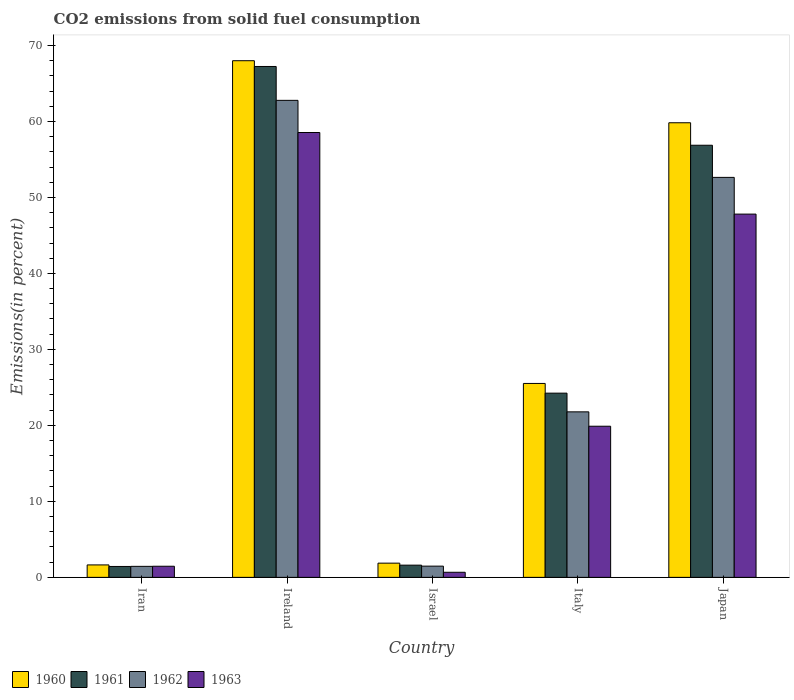How many different coloured bars are there?
Offer a very short reply. 4. How many groups of bars are there?
Your answer should be compact. 5. Are the number of bars per tick equal to the number of legend labels?
Provide a succinct answer. Yes. How many bars are there on the 3rd tick from the left?
Give a very brief answer. 4. What is the total CO2 emitted in 1961 in Japan?
Your response must be concise. 56.87. Across all countries, what is the maximum total CO2 emitted in 1962?
Your response must be concise. 62.77. Across all countries, what is the minimum total CO2 emitted in 1960?
Make the answer very short. 1.64. In which country was the total CO2 emitted in 1962 maximum?
Keep it short and to the point. Ireland. In which country was the total CO2 emitted in 1960 minimum?
Provide a short and direct response. Iran. What is the total total CO2 emitted in 1963 in the graph?
Keep it short and to the point. 128.36. What is the difference between the total CO2 emitted in 1963 in Iran and that in Ireland?
Your answer should be very brief. -57.08. What is the difference between the total CO2 emitted in 1960 in Ireland and the total CO2 emitted in 1961 in Iran?
Provide a succinct answer. 66.55. What is the average total CO2 emitted in 1961 per country?
Your response must be concise. 30.28. What is the difference between the total CO2 emitted of/in 1963 and total CO2 emitted of/in 1960 in Iran?
Your response must be concise. -0.17. What is the ratio of the total CO2 emitted in 1961 in Ireland to that in Italy?
Your answer should be compact. 2.77. Is the total CO2 emitted in 1963 in Ireland less than that in Italy?
Keep it short and to the point. No. Is the difference between the total CO2 emitted in 1963 in Iran and Ireland greater than the difference between the total CO2 emitted in 1960 in Iran and Ireland?
Ensure brevity in your answer.  Yes. What is the difference between the highest and the second highest total CO2 emitted in 1961?
Provide a succinct answer. 32.62. What is the difference between the highest and the lowest total CO2 emitted in 1960?
Your answer should be very brief. 66.35. Is the sum of the total CO2 emitted in 1961 in Iran and Ireland greater than the maximum total CO2 emitted in 1962 across all countries?
Keep it short and to the point. Yes. Is it the case that in every country, the sum of the total CO2 emitted in 1961 and total CO2 emitted in 1960 is greater than the total CO2 emitted in 1963?
Give a very brief answer. Yes. How many bars are there?
Your answer should be compact. 20. How many countries are there in the graph?
Make the answer very short. 5. What is the difference between two consecutive major ticks on the Y-axis?
Your answer should be very brief. 10. Are the values on the major ticks of Y-axis written in scientific E-notation?
Make the answer very short. No. Does the graph contain any zero values?
Provide a succinct answer. No. Does the graph contain grids?
Your answer should be compact. No. How are the legend labels stacked?
Provide a short and direct response. Horizontal. What is the title of the graph?
Provide a short and direct response. CO2 emissions from solid fuel consumption. What is the label or title of the X-axis?
Offer a terse response. Country. What is the label or title of the Y-axis?
Keep it short and to the point. Emissions(in percent). What is the Emissions(in percent) of 1960 in Iran?
Your answer should be very brief. 1.64. What is the Emissions(in percent) in 1961 in Iran?
Your answer should be compact. 1.44. What is the Emissions(in percent) of 1962 in Iran?
Make the answer very short. 1.45. What is the Emissions(in percent) in 1963 in Iran?
Your answer should be compact. 1.46. What is the Emissions(in percent) of 1960 in Ireland?
Offer a terse response. 67.99. What is the Emissions(in percent) of 1961 in Ireland?
Offer a terse response. 67.23. What is the Emissions(in percent) in 1962 in Ireland?
Provide a short and direct response. 62.77. What is the Emissions(in percent) of 1963 in Ireland?
Ensure brevity in your answer.  58.54. What is the Emissions(in percent) of 1960 in Israel?
Your answer should be compact. 1.87. What is the Emissions(in percent) of 1961 in Israel?
Keep it short and to the point. 1.61. What is the Emissions(in percent) in 1962 in Israel?
Your response must be concise. 1.48. What is the Emissions(in percent) of 1963 in Israel?
Your answer should be compact. 0.67. What is the Emissions(in percent) of 1960 in Italy?
Offer a very short reply. 25.52. What is the Emissions(in percent) in 1961 in Italy?
Keep it short and to the point. 24.24. What is the Emissions(in percent) of 1962 in Italy?
Your answer should be compact. 21.78. What is the Emissions(in percent) of 1963 in Italy?
Offer a terse response. 19.89. What is the Emissions(in percent) of 1960 in Japan?
Offer a terse response. 59.82. What is the Emissions(in percent) in 1961 in Japan?
Keep it short and to the point. 56.87. What is the Emissions(in percent) in 1962 in Japan?
Offer a terse response. 52.64. What is the Emissions(in percent) of 1963 in Japan?
Offer a terse response. 47.8. Across all countries, what is the maximum Emissions(in percent) in 1960?
Your response must be concise. 67.99. Across all countries, what is the maximum Emissions(in percent) of 1961?
Your answer should be compact. 67.23. Across all countries, what is the maximum Emissions(in percent) of 1962?
Your answer should be very brief. 62.77. Across all countries, what is the maximum Emissions(in percent) of 1963?
Ensure brevity in your answer.  58.54. Across all countries, what is the minimum Emissions(in percent) in 1960?
Offer a very short reply. 1.64. Across all countries, what is the minimum Emissions(in percent) of 1961?
Your answer should be very brief. 1.44. Across all countries, what is the minimum Emissions(in percent) in 1962?
Offer a very short reply. 1.45. Across all countries, what is the minimum Emissions(in percent) in 1963?
Give a very brief answer. 0.67. What is the total Emissions(in percent) of 1960 in the graph?
Offer a very short reply. 156.84. What is the total Emissions(in percent) of 1961 in the graph?
Your answer should be compact. 151.38. What is the total Emissions(in percent) of 1962 in the graph?
Ensure brevity in your answer.  140.12. What is the total Emissions(in percent) in 1963 in the graph?
Offer a very short reply. 128.36. What is the difference between the Emissions(in percent) of 1960 in Iran and that in Ireland?
Your answer should be compact. -66.35. What is the difference between the Emissions(in percent) of 1961 in Iran and that in Ireland?
Provide a succinct answer. -65.8. What is the difference between the Emissions(in percent) of 1962 in Iran and that in Ireland?
Your response must be concise. -61.32. What is the difference between the Emissions(in percent) in 1963 in Iran and that in Ireland?
Keep it short and to the point. -57.08. What is the difference between the Emissions(in percent) in 1960 in Iran and that in Israel?
Your answer should be very brief. -0.23. What is the difference between the Emissions(in percent) of 1961 in Iran and that in Israel?
Offer a very short reply. -0.17. What is the difference between the Emissions(in percent) in 1962 in Iran and that in Israel?
Provide a short and direct response. -0.03. What is the difference between the Emissions(in percent) in 1963 in Iran and that in Israel?
Your answer should be compact. 0.79. What is the difference between the Emissions(in percent) in 1960 in Iran and that in Italy?
Offer a terse response. -23.88. What is the difference between the Emissions(in percent) of 1961 in Iran and that in Italy?
Offer a very short reply. -22.81. What is the difference between the Emissions(in percent) of 1962 in Iran and that in Italy?
Make the answer very short. -20.33. What is the difference between the Emissions(in percent) in 1963 in Iran and that in Italy?
Keep it short and to the point. -18.42. What is the difference between the Emissions(in percent) of 1960 in Iran and that in Japan?
Ensure brevity in your answer.  -58.19. What is the difference between the Emissions(in percent) of 1961 in Iran and that in Japan?
Ensure brevity in your answer.  -55.43. What is the difference between the Emissions(in percent) of 1962 in Iran and that in Japan?
Offer a very short reply. -51.19. What is the difference between the Emissions(in percent) of 1963 in Iran and that in Japan?
Make the answer very short. -46.34. What is the difference between the Emissions(in percent) in 1960 in Ireland and that in Israel?
Provide a succinct answer. 66.12. What is the difference between the Emissions(in percent) in 1961 in Ireland and that in Israel?
Your answer should be very brief. 65.62. What is the difference between the Emissions(in percent) of 1962 in Ireland and that in Israel?
Offer a very short reply. 61.3. What is the difference between the Emissions(in percent) in 1963 in Ireland and that in Israel?
Your response must be concise. 57.87. What is the difference between the Emissions(in percent) of 1960 in Ireland and that in Italy?
Keep it short and to the point. 42.47. What is the difference between the Emissions(in percent) of 1961 in Ireland and that in Italy?
Provide a succinct answer. 42.99. What is the difference between the Emissions(in percent) in 1962 in Ireland and that in Italy?
Make the answer very short. 40.99. What is the difference between the Emissions(in percent) in 1963 in Ireland and that in Italy?
Your answer should be compact. 38.65. What is the difference between the Emissions(in percent) of 1960 in Ireland and that in Japan?
Give a very brief answer. 8.17. What is the difference between the Emissions(in percent) of 1961 in Ireland and that in Japan?
Offer a terse response. 10.36. What is the difference between the Emissions(in percent) in 1962 in Ireland and that in Japan?
Your answer should be compact. 10.14. What is the difference between the Emissions(in percent) in 1963 in Ireland and that in Japan?
Give a very brief answer. 10.74. What is the difference between the Emissions(in percent) in 1960 in Israel and that in Italy?
Offer a very short reply. -23.65. What is the difference between the Emissions(in percent) of 1961 in Israel and that in Italy?
Keep it short and to the point. -22.63. What is the difference between the Emissions(in percent) of 1962 in Israel and that in Italy?
Your answer should be compact. -20.3. What is the difference between the Emissions(in percent) in 1963 in Israel and that in Italy?
Your answer should be very brief. -19.22. What is the difference between the Emissions(in percent) in 1960 in Israel and that in Japan?
Your response must be concise. -57.95. What is the difference between the Emissions(in percent) of 1961 in Israel and that in Japan?
Ensure brevity in your answer.  -55.26. What is the difference between the Emissions(in percent) in 1962 in Israel and that in Japan?
Your answer should be very brief. -51.16. What is the difference between the Emissions(in percent) in 1963 in Israel and that in Japan?
Give a very brief answer. -47.13. What is the difference between the Emissions(in percent) in 1960 in Italy and that in Japan?
Offer a very short reply. -34.31. What is the difference between the Emissions(in percent) of 1961 in Italy and that in Japan?
Provide a short and direct response. -32.62. What is the difference between the Emissions(in percent) in 1962 in Italy and that in Japan?
Offer a very short reply. -30.86. What is the difference between the Emissions(in percent) of 1963 in Italy and that in Japan?
Provide a short and direct response. -27.91. What is the difference between the Emissions(in percent) in 1960 in Iran and the Emissions(in percent) in 1961 in Ireland?
Make the answer very short. -65.59. What is the difference between the Emissions(in percent) in 1960 in Iran and the Emissions(in percent) in 1962 in Ireland?
Provide a short and direct response. -61.13. What is the difference between the Emissions(in percent) of 1960 in Iran and the Emissions(in percent) of 1963 in Ireland?
Provide a short and direct response. -56.9. What is the difference between the Emissions(in percent) in 1961 in Iran and the Emissions(in percent) in 1962 in Ireland?
Offer a terse response. -61.34. What is the difference between the Emissions(in percent) of 1961 in Iran and the Emissions(in percent) of 1963 in Ireland?
Your answer should be compact. -57.1. What is the difference between the Emissions(in percent) of 1962 in Iran and the Emissions(in percent) of 1963 in Ireland?
Give a very brief answer. -57.09. What is the difference between the Emissions(in percent) in 1960 in Iran and the Emissions(in percent) in 1961 in Israel?
Ensure brevity in your answer.  0.03. What is the difference between the Emissions(in percent) of 1960 in Iran and the Emissions(in percent) of 1962 in Israel?
Make the answer very short. 0.16. What is the difference between the Emissions(in percent) in 1960 in Iran and the Emissions(in percent) in 1963 in Israel?
Your response must be concise. 0.97. What is the difference between the Emissions(in percent) of 1961 in Iran and the Emissions(in percent) of 1962 in Israel?
Make the answer very short. -0.04. What is the difference between the Emissions(in percent) in 1961 in Iran and the Emissions(in percent) in 1963 in Israel?
Make the answer very short. 0.77. What is the difference between the Emissions(in percent) of 1962 in Iran and the Emissions(in percent) of 1963 in Israel?
Your response must be concise. 0.78. What is the difference between the Emissions(in percent) in 1960 in Iran and the Emissions(in percent) in 1961 in Italy?
Make the answer very short. -22.6. What is the difference between the Emissions(in percent) of 1960 in Iran and the Emissions(in percent) of 1962 in Italy?
Make the answer very short. -20.14. What is the difference between the Emissions(in percent) in 1960 in Iran and the Emissions(in percent) in 1963 in Italy?
Give a very brief answer. -18.25. What is the difference between the Emissions(in percent) in 1961 in Iran and the Emissions(in percent) in 1962 in Italy?
Your answer should be compact. -20.35. What is the difference between the Emissions(in percent) in 1961 in Iran and the Emissions(in percent) in 1963 in Italy?
Ensure brevity in your answer.  -18.45. What is the difference between the Emissions(in percent) of 1962 in Iran and the Emissions(in percent) of 1963 in Italy?
Make the answer very short. -18.44. What is the difference between the Emissions(in percent) of 1960 in Iran and the Emissions(in percent) of 1961 in Japan?
Keep it short and to the point. -55.23. What is the difference between the Emissions(in percent) in 1960 in Iran and the Emissions(in percent) in 1962 in Japan?
Your answer should be very brief. -51. What is the difference between the Emissions(in percent) of 1960 in Iran and the Emissions(in percent) of 1963 in Japan?
Keep it short and to the point. -46.17. What is the difference between the Emissions(in percent) of 1961 in Iran and the Emissions(in percent) of 1962 in Japan?
Provide a succinct answer. -51.2. What is the difference between the Emissions(in percent) of 1961 in Iran and the Emissions(in percent) of 1963 in Japan?
Make the answer very short. -46.37. What is the difference between the Emissions(in percent) in 1962 in Iran and the Emissions(in percent) in 1963 in Japan?
Your response must be concise. -46.35. What is the difference between the Emissions(in percent) of 1960 in Ireland and the Emissions(in percent) of 1961 in Israel?
Provide a short and direct response. 66.38. What is the difference between the Emissions(in percent) in 1960 in Ireland and the Emissions(in percent) in 1962 in Israel?
Your response must be concise. 66.51. What is the difference between the Emissions(in percent) in 1960 in Ireland and the Emissions(in percent) in 1963 in Israel?
Offer a terse response. 67.32. What is the difference between the Emissions(in percent) in 1961 in Ireland and the Emissions(in percent) in 1962 in Israel?
Offer a terse response. 65.75. What is the difference between the Emissions(in percent) in 1961 in Ireland and the Emissions(in percent) in 1963 in Israel?
Offer a terse response. 66.56. What is the difference between the Emissions(in percent) in 1962 in Ireland and the Emissions(in percent) in 1963 in Israel?
Keep it short and to the point. 62.1. What is the difference between the Emissions(in percent) in 1960 in Ireland and the Emissions(in percent) in 1961 in Italy?
Make the answer very short. 43.75. What is the difference between the Emissions(in percent) of 1960 in Ireland and the Emissions(in percent) of 1962 in Italy?
Offer a very short reply. 46.21. What is the difference between the Emissions(in percent) of 1960 in Ireland and the Emissions(in percent) of 1963 in Italy?
Ensure brevity in your answer.  48.1. What is the difference between the Emissions(in percent) of 1961 in Ireland and the Emissions(in percent) of 1962 in Italy?
Ensure brevity in your answer.  45.45. What is the difference between the Emissions(in percent) in 1961 in Ireland and the Emissions(in percent) in 1963 in Italy?
Give a very brief answer. 47.34. What is the difference between the Emissions(in percent) of 1962 in Ireland and the Emissions(in percent) of 1963 in Italy?
Make the answer very short. 42.88. What is the difference between the Emissions(in percent) in 1960 in Ireland and the Emissions(in percent) in 1961 in Japan?
Ensure brevity in your answer.  11.12. What is the difference between the Emissions(in percent) of 1960 in Ireland and the Emissions(in percent) of 1962 in Japan?
Give a very brief answer. 15.35. What is the difference between the Emissions(in percent) of 1960 in Ireland and the Emissions(in percent) of 1963 in Japan?
Your answer should be very brief. 20.19. What is the difference between the Emissions(in percent) in 1961 in Ireland and the Emissions(in percent) in 1962 in Japan?
Make the answer very short. 14.59. What is the difference between the Emissions(in percent) in 1961 in Ireland and the Emissions(in percent) in 1963 in Japan?
Ensure brevity in your answer.  19.43. What is the difference between the Emissions(in percent) of 1962 in Ireland and the Emissions(in percent) of 1963 in Japan?
Make the answer very short. 14.97. What is the difference between the Emissions(in percent) in 1960 in Israel and the Emissions(in percent) in 1961 in Italy?
Provide a short and direct response. -22.37. What is the difference between the Emissions(in percent) in 1960 in Israel and the Emissions(in percent) in 1962 in Italy?
Offer a very short reply. -19.91. What is the difference between the Emissions(in percent) in 1960 in Israel and the Emissions(in percent) in 1963 in Italy?
Offer a terse response. -18.02. What is the difference between the Emissions(in percent) in 1961 in Israel and the Emissions(in percent) in 1962 in Italy?
Provide a short and direct response. -20.17. What is the difference between the Emissions(in percent) in 1961 in Israel and the Emissions(in percent) in 1963 in Italy?
Make the answer very short. -18.28. What is the difference between the Emissions(in percent) of 1962 in Israel and the Emissions(in percent) of 1963 in Italy?
Provide a succinct answer. -18.41. What is the difference between the Emissions(in percent) of 1960 in Israel and the Emissions(in percent) of 1961 in Japan?
Ensure brevity in your answer.  -54.99. What is the difference between the Emissions(in percent) in 1960 in Israel and the Emissions(in percent) in 1962 in Japan?
Ensure brevity in your answer.  -50.77. What is the difference between the Emissions(in percent) in 1960 in Israel and the Emissions(in percent) in 1963 in Japan?
Offer a terse response. -45.93. What is the difference between the Emissions(in percent) of 1961 in Israel and the Emissions(in percent) of 1962 in Japan?
Your answer should be compact. -51.03. What is the difference between the Emissions(in percent) in 1961 in Israel and the Emissions(in percent) in 1963 in Japan?
Provide a succinct answer. -46.2. What is the difference between the Emissions(in percent) in 1962 in Israel and the Emissions(in percent) in 1963 in Japan?
Your response must be concise. -46.33. What is the difference between the Emissions(in percent) in 1960 in Italy and the Emissions(in percent) in 1961 in Japan?
Give a very brief answer. -31.35. What is the difference between the Emissions(in percent) of 1960 in Italy and the Emissions(in percent) of 1962 in Japan?
Give a very brief answer. -27.12. What is the difference between the Emissions(in percent) of 1960 in Italy and the Emissions(in percent) of 1963 in Japan?
Your answer should be very brief. -22.28. What is the difference between the Emissions(in percent) in 1961 in Italy and the Emissions(in percent) in 1962 in Japan?
Offer a very short reply. -28.39. What is the difference between the Emissions(in percent) of 1961 in Italy and the Emissions(in percent) of 1963 in Japan?
Offer a very short reply. -23.56. What is the difference between the Emissions(in percent) of 1962 in Italy and the Emissions(in percent) of 1963 in Japan?
Give a very brief answer. -26.02. What is the average Emissions(in percent) of 1960 per country?
Ensure brevity in your answer.  31.37. What is the average Emissions(in percent) in 1961 per country?
Provide a short and direct response. 30.28. What is the average Emissions(in percent) in 1962 per country?
Make the answer very short. 28.02. What is the average Emissions(in percent) of 1963 per country?
Offer a very short reply. 25.67. What is the difference between the Emissions(in percent) of 1960 and Emissions(in percent) of 1961 in Iran?
Your answer should be very brief. 0.2. What is the difference between the Emissions(in percent) in 1960 and Emissions(in percent) in 1962 in Iran?
Provide a succinct answer. 0.19. What is the difference between the Emissions(in percent) in 1960 and Emissions(in percent) in 1963 in Iran?
Make the answer very short. 0.17. What is the difference between the Emissions(in percent) in 1961 and Emissions(in percent) in 1962 in Iran?
Make the answer very short. -0.01. What is the difference between the Emissions(in percent) in 1961 and Emissions(in percent) in 1963 in Iran?
Provide a succinct answer. -0.03. What is the difference between the Emissions(in percent) of 1962 and Emissions(in percent) of 1963 in Iran?
Your answer should be compact. -0.01. What is the difference between the Emissions(in percent) of 1960 and Emissions(in percent) of 1961 in Ireland?
Your response must be concise. 0.76. What is the difference between the Emissions(in percent) in 1960 and Emissions(in percent) in 1962 in Ireland?
Offer a very short reply. 5.22. What is the difference between the Emissions(in percent) of 1960 and Emissions(in percent) of 1963 in Ireland?
Ensure brevity in your answer.  9.45. What is the difference between the Emissions(in percent) of 1961 and Emissions(in percent) of 1962 in Ireland?
Your response must be concise. 4.46. What is the difference between the Emissions(in percent) of 1961 and Emissions(in percent) of 1963 in Ireland?
Provide a succinct answer. 8.69. What is the difference between the Emissions(in percent) in 1962 and Emissions(in percent) in 1963 in Ireland?
Offer a very short reply. 4.23. What is the difference between the Emissions(in percent) in 1960 and Emissions(in percent) in 1961 in Israel?
Offer a terse response. 0.26. What is the difference between the Emissions(in percent) of 1960 and Emissions(in percent) of 1962 in Israel?
Offer a terse response. 0.39. What is the difference between the Emissions(in percent) of 1960 and Emissions(in percent) of 1963 in Israel?
Offer a terse response. 1.2. What is the difference between the Emissions(in percent) of 1961 and Emissions(in percent) of 1962 in Israel?
Ensure brevity in your answer.  0.13. What is the difference between the Emissions(in percent) in 1961 and Emissions(in percent) in 1963 in Israel?
Your answer should be very brief. 0.94. What is the difference between the Emissions(in percent) of 1962 and Emissions(in percent) of 1963 in Israel?
Give a very brief answer. 0.81. What is the difference between the Emissions(in percent) in 1960 and Emissions(in percent) in 1961 in Italy?
Your response must be concise. 1.28. What is the difference between the Emissions(in percent) in 1960 and Emissions(in percent) in 1962 in Italy?
Your answer should be compact. 3.74. What is the difference between the Emissions(in percent) of 1960 and Emissions(in percent) of 1963 in Italy?
Offer a terse response. 5.63. What is the difference between the Emissions(in percent) of 1961 and Emissions(in percent) of 1962 in Italy?
Your answer should be very brief. 2.46. What is the difference between the Emissions(in percent) of 1961 and Emissions(in percent) of 1963 in Italy?
Offer a very short reply. 4.35. What is the difference between the Emissions(in percent) in 1962 and Emissions(in percent) in 1963 in Italy?
Offer a terse response. 1.89. What is the difference between the Emissions(in percent) of 1960 and Emissions(in percent) of 1961 in Japan?
Give a very brief answer. 2.96. What is the difference between the Emissions(in percent) of 1960 and Emissions(in percent) of 1962 in Japan?
Ensure brevity in your answer.  7.19. What is the difference between the Emissions(in percent) of 1960 and Emissions(in percent) of 1963 in Japan?
Provide a short and direct response. 12.02. What is the difference between the Emissions(in percent) of 1961 and Emissions(in percent) of 1962 in Japan?
Provide a succinct answer. 4.23. What is the difference between the Emissions(in percent) of 1961 and Emissions(in percent) of 1963 in Japan?
Offer a very short reply. 9.06. What is the difference between the Emissions(in percent) of 1962 and Emissions(in percent) of 1963 in Japan?
Make the answer very short. 4.83. What is the ratio of the Emissions(in percent) of 1960 in Iran to that in Ireland?
Offer a terse response. 0.02. What is the ratio of the Emissions(in percent) of 1961 in Iran to that in Ireland?
Your answer should be compact. 0.02. What is the ratio of the Emissions(in percent) of 1962 in Iran to that in Ireland?
Your answer should be very brief. 0.02. What is the ratio of the Emissions(in percent) of 1963 in Iran to that in Ireland?
Make the answer very short. 0.03. What is the ratio of the Emissions(in percent) in 1960 in Iran to that in Israel?
Ensure brevity in your answer.  0.88. What is the ratio of the Emissions(in percent) in 1961 in Iran to that in Israel?
Your response must be concise. 0.89. What is the ratio of the Emissions(in percent) in 1962 in Iran to that in Israel?
Your response must be concise. 0.98. What is the ratio of the Emissions(in percent) in 1963 in Iran to that in Israel?
Make the answer very short. 2.18. What is the ratio of the Emissions(in percent) of 1960 in Iran to that in Italy?
Give a very brief answer. 0.06. What is the ratio of the Emissions(in percent) in 1961 in Iran to that in Italy?
Make the answer very short. 0.06. What is the ratio of the Emissions(in percent) of 1962 in Iran to that in Italy?
Provide a succinct answer. 0.07. What is the ratio of the Emissions(in percent) in 1963 in Iran to that in Italy?
Your answer should be very brief. 0.07. What is the ratio of the Emissions(in percent) in 1960 in Iran to that in Japan?
Ensure brevity in your answer.  0.03. What is the ratio of the Emissions(in percent) of 1961 in Iran to that in Japan?
Your answer should be very brief. 0.03. What is the ratio of the Emissions(in percent) of 1962 in Iran to that in Japan?
Make the answer very short. 0.03. What is the ratio of the Emissions(in percent) in 1963 in Iran to that in Japan?
Offer a terse response. 0.03. What is the ratio of the Emissions(in percent) of 1960 in Ireland to that in Israel?
Your answer should be very brief. 36.34. What is the ratio of the Emissions(in percent) in 1961 in Ireland to that in Israel?
Ensure brevity in your answer.  41.81. What is the ratio of the Emissions(in percent) of 1962 in Ireland to that in Israel?
Offer a very short reply. 42.49. What is the ratio of the Emissions(in percent) of 1963 in Ireland to that in Israel?
Give a very brief answer. 87.38. What is the ratio of the Emissions(in percent) of 1960 in Ireland to that in Italy?
Make the answer very short. 2.66. What is the ratio of the Emissions(in percent) of 1961 in Ireland to that in Italy?
Your answer should be compact. 2.77. What is the ratio of the Emissions(in percent) in 1962 in Ireland to that in Italy?
Offer a very short reply. 2.88. What is the ratio of the Emissions(in percent) of 1963 in Ireland to that in Italy?
Offer a terse response. 2.94. What is the ratio of the Emissions(in percent) of 1960 in Ireland to that in Japan?
Give a very brief answer. 1.14. What is the ratio of the Emissions(in percent) of 1961 in Ireland to that in Japan?
Keep it short and to the point. 1.18. What is the ratio of the Emissions(in percent) in 1962 in Ireland to that in Japan?
Make the answer very short. 1.19. What is the ratio of the Emissions(in percent) in 1963 in Ireland to that in Japan?
Give a very brief answer. 1.22. What is the ratio of the Emissions(in percent) in 1960 in Israel to that in Italy?
Your answer should be compact. 0.07. What is the ratio of the Emissions(in percent) in 1961 in Israel to that in Italy?
Make the answer very short. 0.07. What is the ratio of the Emissions(in percent) of 1962 in Israel to that in Italy?
Ensure brevity in your answer.  0.07. What is the ratio of the Emissions(in percent) in 1963 in Israel to that in Italy?
Offer a terse response. 0.03. What is the ratio of the Emissions(in percent) in 1960 in Israel to that in Japan?
Your answer should be compact. 0.03. What is the ratio of the Emissions(in percent) of 1961 in Israel to that in Japan?
Your answer should be compact. 0.03. What is the ratio of the Emissions(in percent) of 1962 in Israel to that in Japan?
Your answer should be very brief. 0.03. What is the ratio of the Emissions(in percent) in 1963 in Israel to that in Japan?
Provide a succinct answer. 0.01. What is the ratio of the Emissions(in percent) in 1960 in Italy to that in Japan?
Your answer should be very brief. 0.43. What is the ratio of the Emissions(in percent) of 1961 in Italy to that in Japan?
Keep it short and to the point. 0.43. What is the ratio of the Emissions(in percent) in 1962 in Italy to that in Japan?
Make the answer very short. 0.41. What is the ratio of the Emissions(in percent) of 1963 in Italy to that in Japan?
Provide a succinct answer. 0.42. What is the difference between the highest and the second highest Emissions(in percent) of 1960?
Your response must be concise. 8.17. What is the difference between the highest and the second highest Emissions(in percent) of 1961?
Offer a terse response. 10.36. What is the difference between the highest and the second highest Emissions(in percent) in 1962?
Give a very brief answer. 10.14. What is the difference between the highest and the second highest Emissions(in percent) of 1963?
Your answer should be very brief. 10.74. What is the difference between the highest and the lowest Emissions(in percent) of 1960?
Provide a succinct answer. 66.35. What is the difference between the highest and the lowest Emissions(in percent) of 1961?
Your response must be concise. 65.8. What is the difference between the highest and the lowest Emissions(in percent) in 1962?
Offer a very short reply. 61.32. What is the difference between the highest and the lowest Emissions(in percent) of 1963?
Provide a short and direct response. 57.87. 